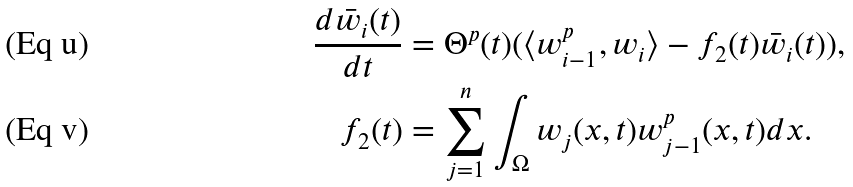Convert formula to latex. <formula><loc_0><loc_0><loc_500><loc_500>\frac { d \bar { w } _ { i } ( t ) } { d t } & = \Theta ^ { p } ( t ) ( \langle w _ { i - 1 } ^ { p } , w _ { i } \rangle - f _ { 2 } ( t ) \bar { w } _ { i } ( t ) ) , \\ f _ { 2 } ( t ) & = \sum _ { j = 1 } ^ { n } \int _ { \Omega } w _ { j } ( x , t ) w _ { j - 1 } ^ { p } ( x , t ) d x .</formula> 